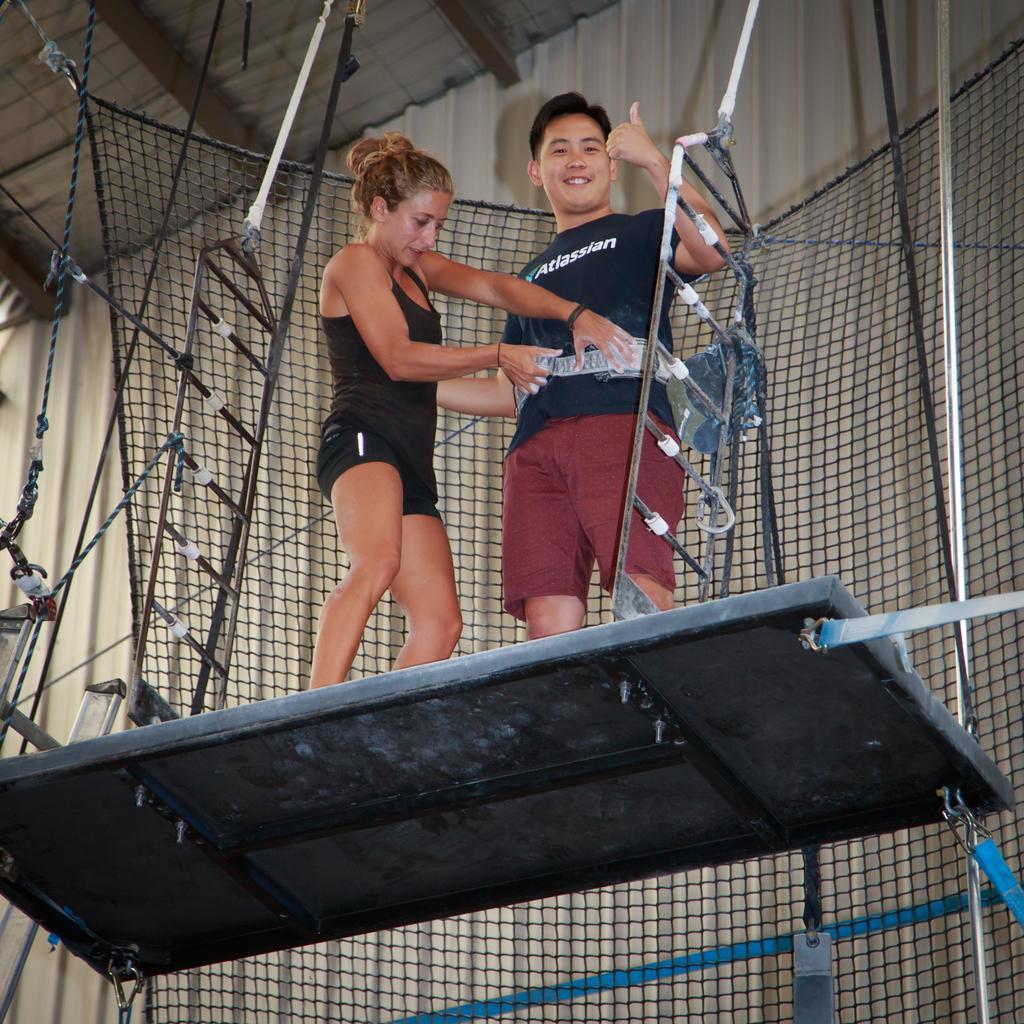Describe this image in one or two sentences. There are two persons standing on an object and there are some other objects and a net behind it. 